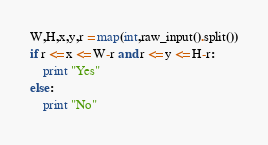Convert code to text. <code><loc_0><loc_0><loc_500><loc_500><_Python_>W,H,x,y,r = map(int,raw_input().split())
if r <= x <= W-r and r <= y <= H-r:
	print "Yes"
else:
	print "No"</code> 